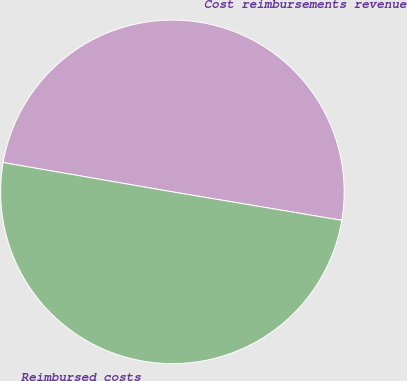Convert chart. <chart><loc_0><loc_0><loc_500><loc_500><pie_chart><fcel>Cost reimbursements revenue<fcel>Reimbursed costs<nl><fcel>49.92%<fcel>50.08%<nl></chart> 